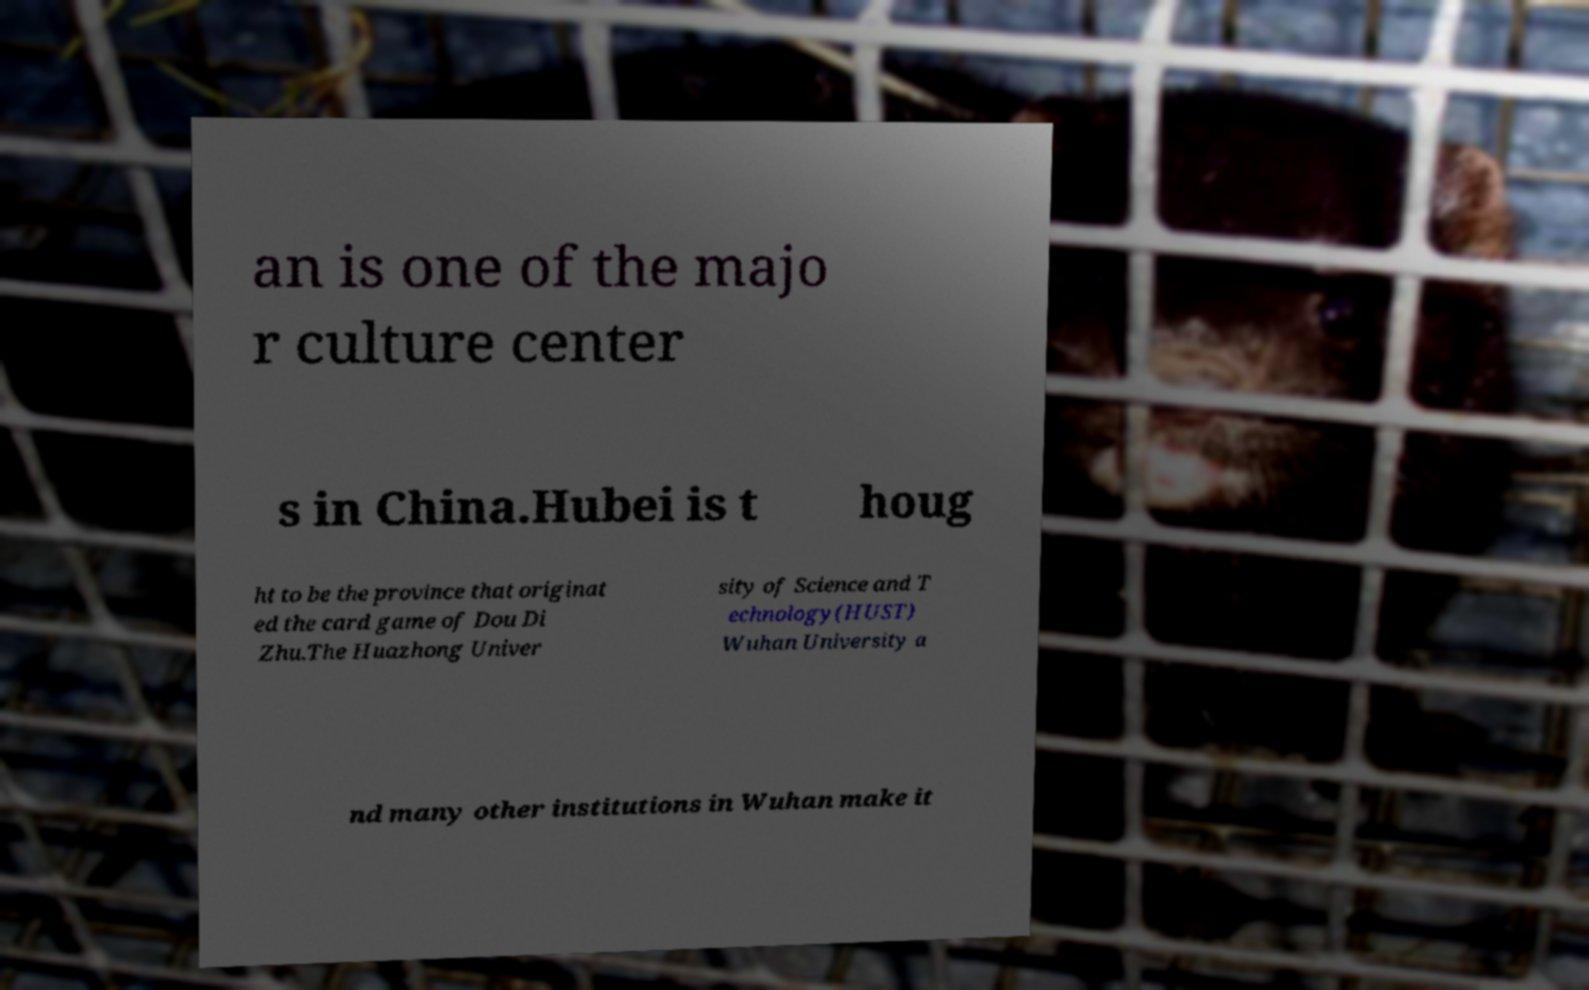Can you read and provide the text displayed in the image?This photo seems to have some interesting text. Can you extract and type it out for me? an is one of the majo r culture center s in China.Hubei is t houg ht to be the province that originat ed the card game of Dou Di Zhu.The Huazhong Univer sity of Science and T echnology(HUST) Wuhan University a nd many other institutions in Wuhan make it 